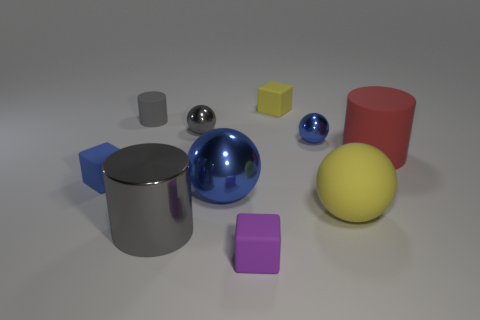What are the different shapes and colors of objects visible in the image? The image showcases a variety of geometric shapes. There's a large matte gray cube, a small shiny silver sphere, a medium-sized shiny blue sphere, and a large glossy yellow sphere. Additionally, there's a small yellow cube, a tiny matte pink cube, a large matte blue cylinder, and a large glossy red cylinder. The scene captures a mix of matte, glossy, and shiny textures with a diverse color palette including gray, silver, blue, yellow, pink, and red. 